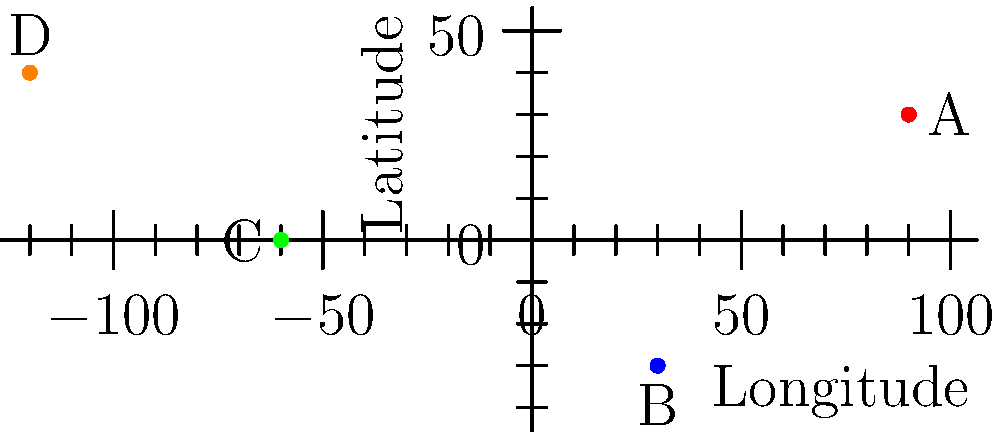As part of your initiative to diversify the museum's collection, you've identified four potential art pieces from different parts of the world. Their approximate geographical origins are plotted on the world map above using a coordinate system where longitude ranges from -180° to 180° and latitude from -90° to 90°. Which art piece originates closest to the equator? To determine which art piece originates closest to the equator, we need to compare the absolute values of the latitudes for each point, as the equator is at 0° latitude. Let's examine each point:

1. Point A (red): Located at approximately (90°E, 30°N)
   Absolute latitude: |30°| = 30°

2. Point B (blue): Located at approximately (30°E, 30°S)
   Absolute latitude: |-30°| = 30°

3. Point C (green): Located at approximately (60°W, 0°)
   Absolute latitude: |0°| = 0°

4. Point D (orange): Located at approximately (120°W, 40°N)
   Absolute latitude: |40°| = 40°

The point with the smallest absolute latitude value is closest to the equator. In this case, Point C has a latitude of 0°, which means it lies directly on the equator.

Therefore, the art piece originating from Point C is closest to the equator.
Answer: C 